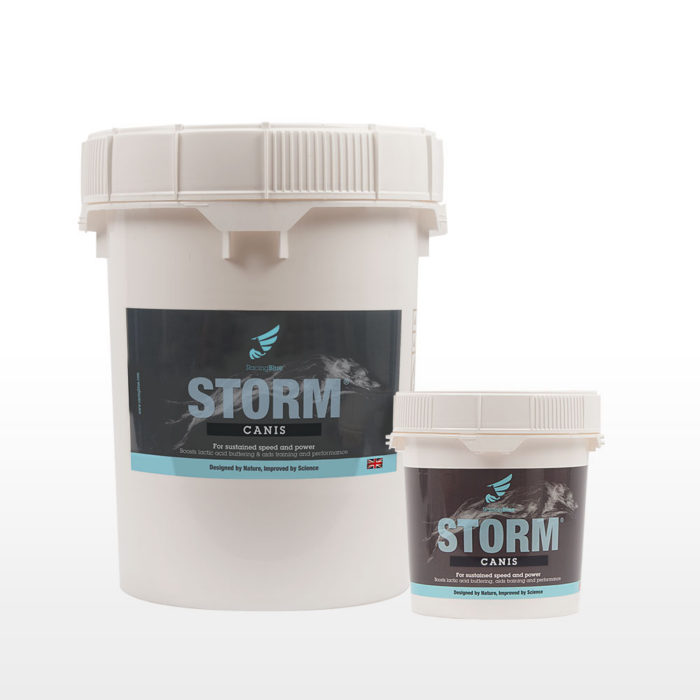How does the branding strategy of STORM CANIS appeal to dog owners? The branding of STORM CANIS utilizes a sleek, modern design with images of swift, dynamic dogs, appealing directly to owners who are keen on maintaining their pet’s health and performance. The use of the phrase 'Designed by Nature, Improved by Science' also taps into the growing trend of scientifically supported natural supplements, reassuring owners who are concerned about the well-being and peak performance of their dogs. 